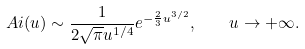Convert formula to latex. <formula><loc_0><loc_0><loc_500><loc_500>A i ( u ) \sim \frac { 1 } { 2 \sqrt { \pi } u ^ { 1 / 4 } } e ^ { - \frac { 2 } { 3 } u ^ { 3 / 2 } } , \quad u \to + \infty .</formula> 